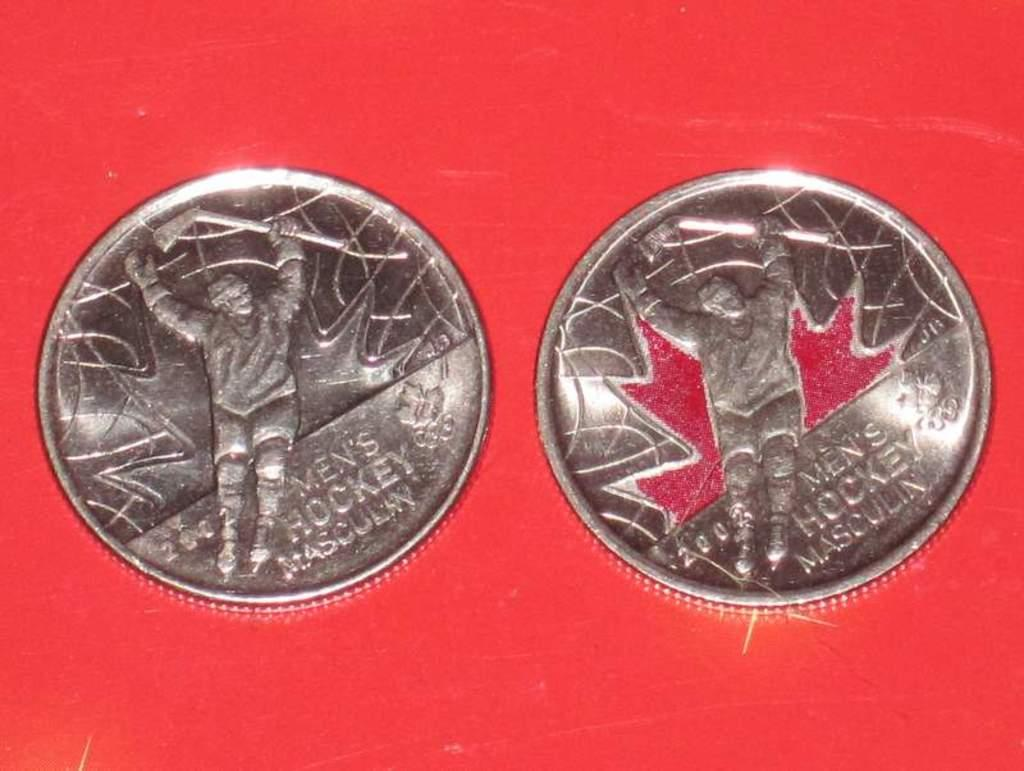<image>
Give a short and clear explanation of the subsequent image. A couple of Mens Hockey Masculine coins on a red table. 